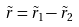<formula> <loc_0><loc_0><loc_500><loc_500>\tilde { r } = \tilde { r } _ { 1 } - \tilde { r } _ { 2 }</formula> 